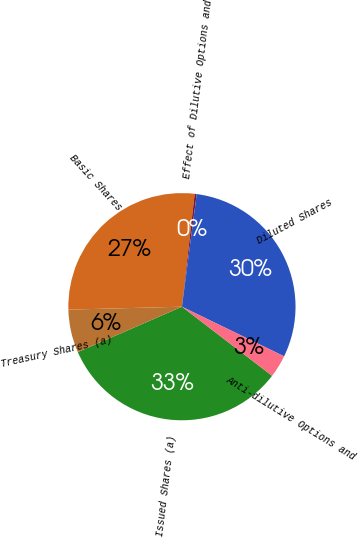Convert chart. <chart><loc_0><loc_0><loc_500><loc_500><pie_chart><fcel>Issued Shares (a)<fcel>Treasury Shares (a)<fcel>Basic Shares<fcel>Effect of Dilutive Options and<fcel>Diluted Shares<fcel>Anti-dilutive Options and<nl><fcel>33.05%<fcel>6.13%<fcel>27.2%<fcel>0.29%<fcel>30.12%<fcel>3.21%<nl></chart> 